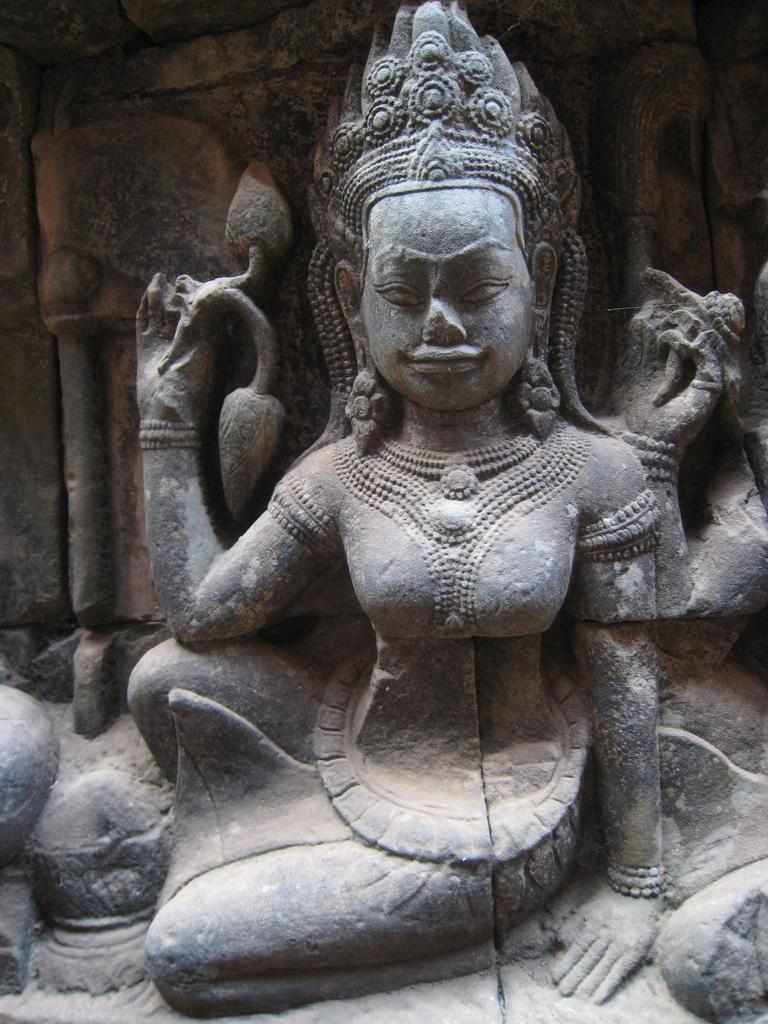What is the main subject in the image? There is an idol statue in the image. What can be seen in the background of the image? There is a wall in the background of the image. How many masks are hanging on the wall in the image? There are no masks present in the image; it only features an idol statue and a wall in the background. 